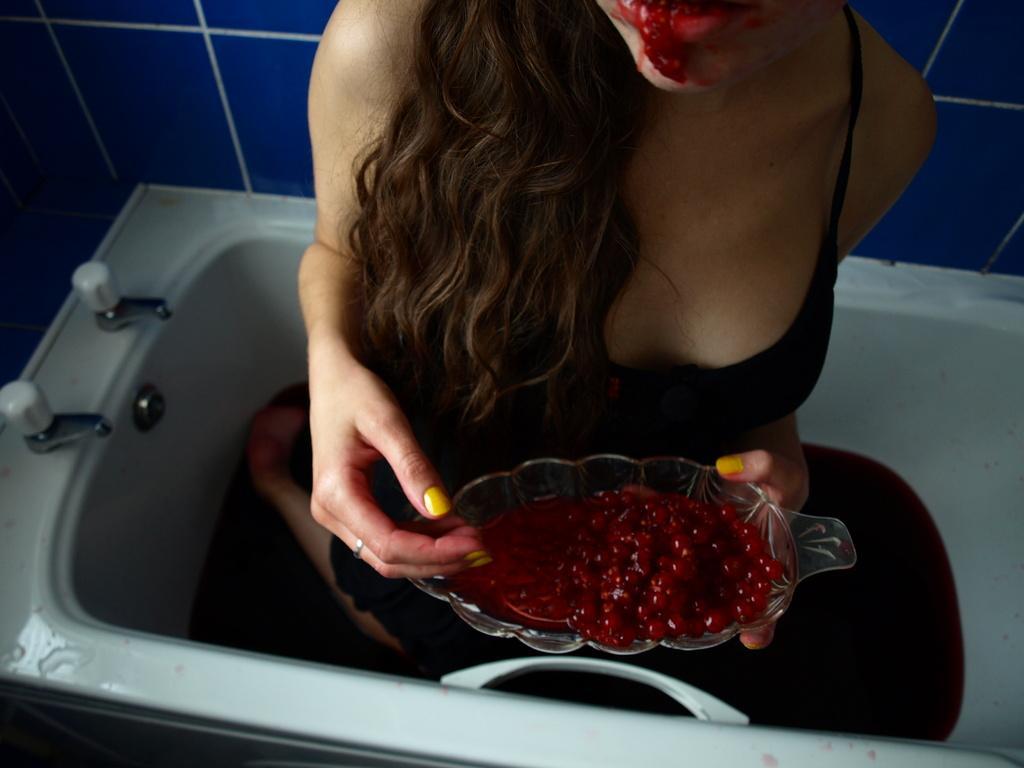Could you give a brief overview of what you see in this image? In the middle of this image, there is a woman in a black color dress, holding a bowl, which is having red color fruits. This woman is in the white color tub, which is having two taps. In the background, there is a violet color wall. 